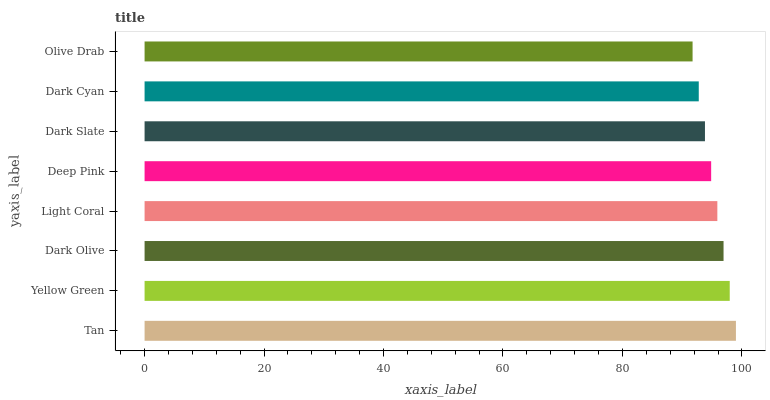Is Olive Drab the minimum?
Answer yes or no. Yes. Is Tan the maximum?
Answer yes or no. Yes. Is Yellow Green the minimum?
Answer yes or no. No. Is Yellow Green the maximum?
Answer yes or no. No. Is Tan greater than Yellow Green?
Answer yes or no. Yes. Is Yellow Green less than Tan?
Answer yes or no. Yes. Is Yellow Green greater than Tan?
Answer yes or no. No. Is Tan less than Yellow Green?
Answer yes or no. No. Is Light Coral the high median?
Answer yes or no. Yes. Is Deep Pink the low median?
Answer yes or no. Yes. Is Tan the high median?
Answer yes or no. No. Is Yellow Green the low median?
Answer yes or no. No. 